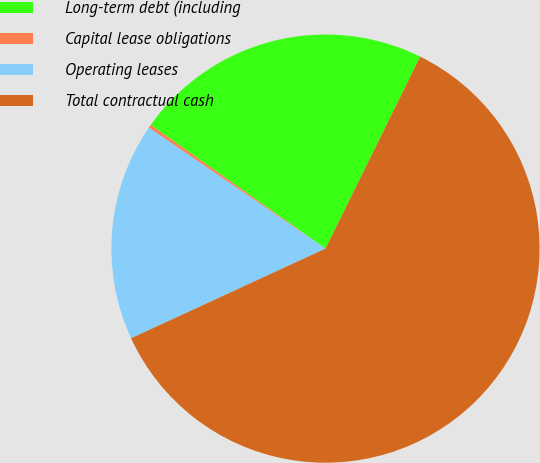Convert chart. <chart><loc_0><loc_0><loc_500><loc_500><pie_chart><fcel>Long-term debt (including<fcel>Capital lease obligations<fcel>Operating leases<fcel>Total contractual cash<nl><fcel>22.49%<fcel>0.25%<fcel>16.43%<fcel>60.83%<nl></chart> 